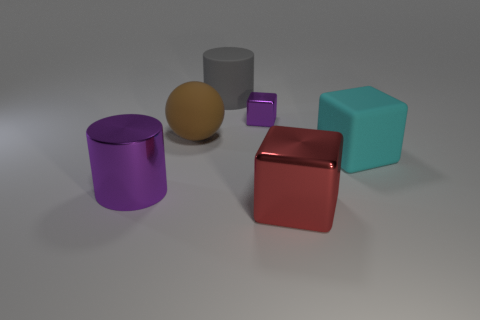Can you describe the lighting in the scene? The lighting in the scene appears to come from the upper left, casting soft shadows to the right of the objects. This subtle lighting creates a calm atmosphere and enhances the three-dimensional feel of the shapes. 